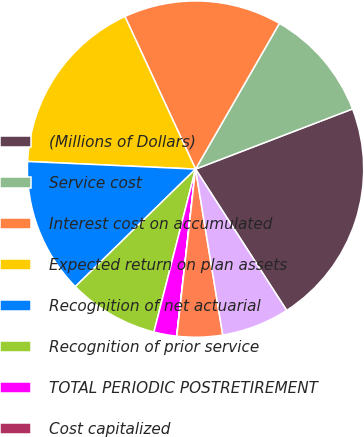<chart> <loc_0><loc_0><loc_500><loc_500><pie_chart><fcel>(Millions of Dollars)<fcel>Service cost<fcel>Interest cost on accumulated<fcel>Expected return on plan assets<fcel>Recognition of net actuarial<fcel>Recognition of prior service<fcel>TOTAL PERIODIC POSTRETIREMENT<fcel>Cost capitalized<fcel>Reconciliation to rate level<fcel>Cost charged to operating<nl><fcel>21.71%<fcel>10.87%<fcel>15.21%<fcel>17.38%<fcel>13.04%<fcel>8.7%<fcel>2.19%<fcel>0.02%<fcel>4.36%<fcel>6.53%<nl></chart> 